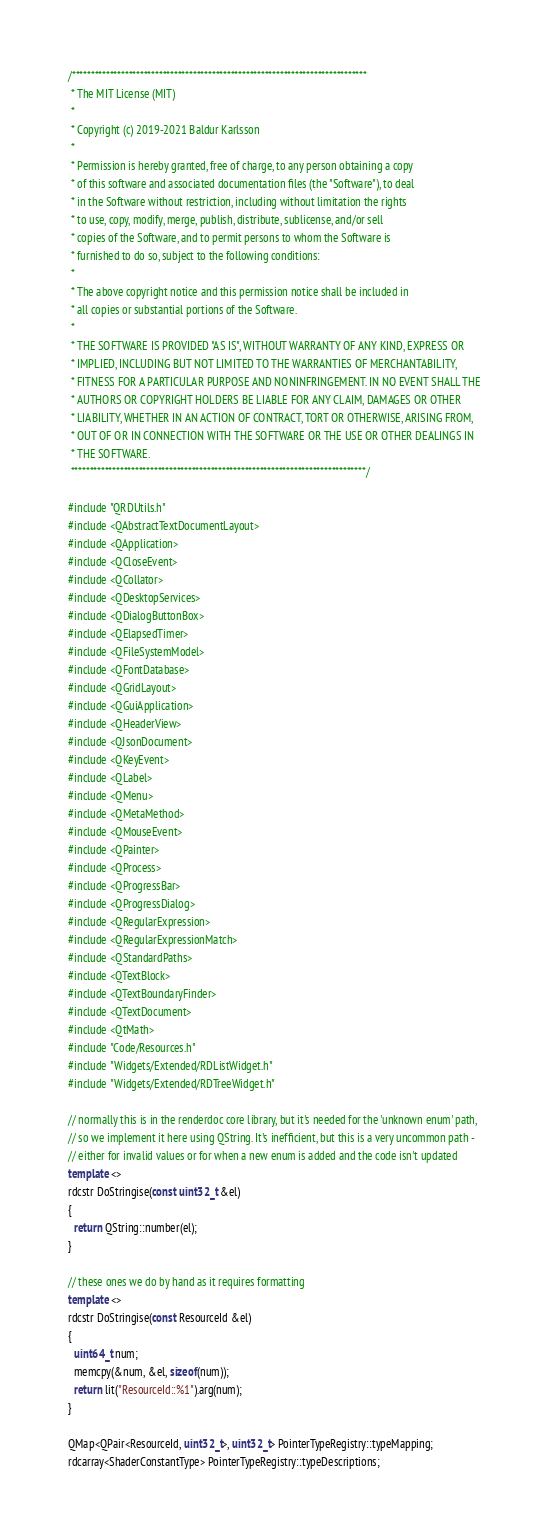<code> <loc_0><loc_0><loc_500><loc_500><_C++_>/******************************************************************************
 * The MIT License (MIT)
 *
 * Copyright (c) 2019-2021 Baldur Karlsson
 *
 * Permission is hereby granted, free of charge, to any person obtaining a copy
 * of this software and associated documentation files (the "Software"), to deal
 * in the Software without restriction, including without limitation the rights
 * to use, copy, modify, merge, publish, distribute, sublicense, and/or sell
 * copies of the Software, and to permit persons to whom the Software is
 * furnished to do so, subject to the following conditions:
 *
 * The above copyright notice and this permission notice shall be included in
 * all copies or substantial portions of the Software.
 *
 * THE SOFTWARE IS PROVIDED "AS IS", WITHOUT WARRANTY OF ANY KIND, EXPRESS OR
 * IMPLIED, INCLUDING BUT NOT LIMITED TO THE WARRANTIES OF MERCHANTABILITY,
 * FITNESS FOR A PARTICULAR PURPOSE AND NONINFRINGEMENT. IN NO EVENT SHALL THE
 * AUTHORS OR COPYRIGHT HOLDERS BE LIABLE FOR ANY CLAIM, DAMAGES OR OTHER
 * LIABILITY, WHETHER IN AN ACTION OF CONTRACT, TORT OR OTHERWISE, ARISING FROM,
 * OUT OF OR IN CONNECTION WITH THE SOFTWARE OR THE USE OR OTHER DEALINGS IN
 * THE SOFTWARE.
 ******************************************************************************/

#include "QRDUtils.h"
#include <QAbstractTextDocumentLayout>
#include <QApplication>
#include <QCloseEvent>
#include <QCollator>
#include <QDesktopServices>
#include <QDialogButtonBox>
#include <QElapsedTimer>
#include <QFileSystemModel>
#include <QFontDatabase>
#include <QGridLayout>
#include <QGuiApplication>
#include <QHeaderView>
#include <QJsonDocument>
#include <QKeyEvent>
#include <QLabel>
#include <QMenu>
#include <QMetaMethod>
#include <QMouseEvent>
#include <QPainter>
#include <QProcess>
#include <QProgressBar>
#include <QProgressDialog>
#include <QRegularExpression>
#include <QRegularExpressionMatch>
#include <QStandardPaths>
#include <QTextBlock>
#include <QTextBoundaryFinder>
#include <QTextDocument>
#include <QtMath>
#include "Code/Resources.h"
#include "Widgets/Extended/RDListWidget.h"
#include "Widgets/Extended/RDTreeWidget.h"

// normally this is in the renderdoc core library, but it's needed for the 'unknown enum' path,
// so we implement it here using QString. It's inefficient, but this is a very uncommon path -
// either for invalid values or for when a new enum is added and the code isn't updated
template <>
rdcstr DoStringise(const uint32_t &el)
{
  return QString::number(el);
}

// these ones we do by hand as it requires formatting
template <>
rdcstr DoStringise(const ResourceId &el)
{
  uint64_t num;
  memcpy(&num, &el, sizeof(num));
  return lit("ResourceId::%1").arg(num);
}

QMap<QPair<ResourceId, uint32_t>, uint32_t> PointerTypeRegistry::typeMapping;
rdcarray<ShaderConstantType> PointerTypeRegistry::typeDescriptions;
</code> 